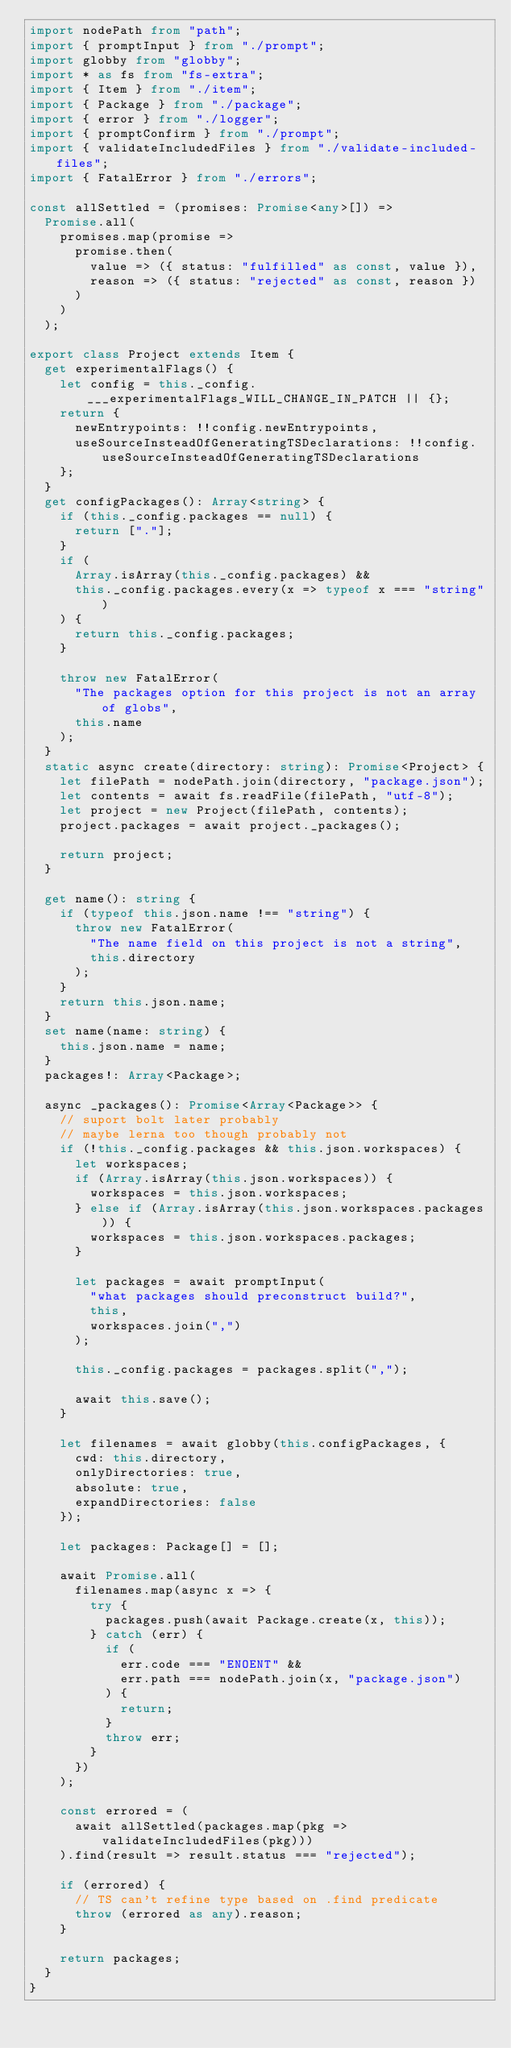Convert code to text. <code><loc_0><loc_0><loc_500><loc_500><_TypeScript_>import nodePath from "path";
import { promptInput } from "./prompt";
import globby from "globby";
import * as fs from "fs-extra";
import { Item } from "./item";
import { Package } from "./package";
import { error } from "./logger";
import { promptConfirm } from "./prompt";
import { validateIncludedFiles } from "./validate-included-files";
import { FatalError } from "./errors";

const allSettled = (promises: Promise<any>[]) =>
  Promise.all(
    promises.map(promise =>
      promise.then(
        value => ({ status: "fulfilled" as const, value }),
        reason => ({ status: "rejected" as const, reason })
      )
    )
  );

export class Project extends Item {
  get experimentalFlags() {
    let config = this._config.___experimentalFlags_WILL_CHANGE_IN_PATCH || {};
    return {
      newEntrypoints: !!config.newEntrypoints,
      useSourceInsteadOfGeneratingTSDeclarations: !!config.useSourceInsteadOfGeneratingTSDeclarations
    };
  }
  get configPackages(): Array<string> {
    if (this._config.packages == null) {
      return ["."];
    }
    if (
      Array.isArray(this._config.packages) &&
      this._config.packages.every(x => typeof x === "string")
    ) {
      return this._config.packages;
    }

    throw new FatalError(
      "The packages option for this project is not an array of globs",
      this.name
    );
  }
  static async create(directory: string): Promise<Project> {
    let filePath = nodePath.join(directory, "package.json");
    let contents = await fs.readFile(filePath, "utf-8");
    let project = new Project(filePath, contents);
    project.packages = await project._packages();

    return project;
  }

  get name(): string {
    if (typeof this.json.name !== "string") {
      throw new FatalError(
        "The name field on this project is not a string",
        this.directory
      );
    }
    return this.json.name;
  }
  set name(name: string) {
    this.json.name = name;
  }
  packages!: Array<Package>;

  async _packages(): Promise<Array<Package>> {
    // suport bolt later probably
    // maybe lerna too though probably not
    if (!this._config.packages && this.json.workspaces) {
      let workspaces;
      if (Array.isArray(this.json.workspaces)) {
        workspaces = this.json.workspaces;
      } else if (Array.isArray(this.json.workspaces.packages)) {
        workspaces = this.json.workspaces.packages;
      }

      let packages = await promptInput(
        "what packages should preconstruct build?",
        this,
        workspaces.join(",")
      );

      this._config.packages = packages.split(",");

      await this.save();
    }

    let filenames = await globby(this.configPackages, {
      cwd: this.directory,
      onlyDirectories: true,
      absolute: true,
      expandDirectories: false
    });

    let packages: Package[] = [];

    await Promise.all(
      filenames.map(async x => {
        try {
          packages.push(await Package.create(x, this));
        } catch (err) {
          if (
            err.code === "ENOENT" &&
            err.path === nodePath.join(x, "package.json")
          ) {
            return;
          }
          throw err;
        }
      })
    );

    const errored = (
      await allSettled(packages.map(pkg => validateIncludedFiles(pkg)))
    ).find(result => result.status === "rejected");

    if (errored) {
      // TS can't refine type based on .find predicate
      throw (errored as any).reason;
    }

    return packages;
  }
}
</code> 